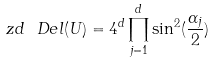<formula> <loc_0><loc_0><loc_500><loc_500>\ z d \ D e l ( U ) = 4 ^ { d } \prod ^ { d } _ { j = 1 } \sin ^ { 2 } ( \frac { \alpha _ { j } } { 2 } ) \ \,</formula> 